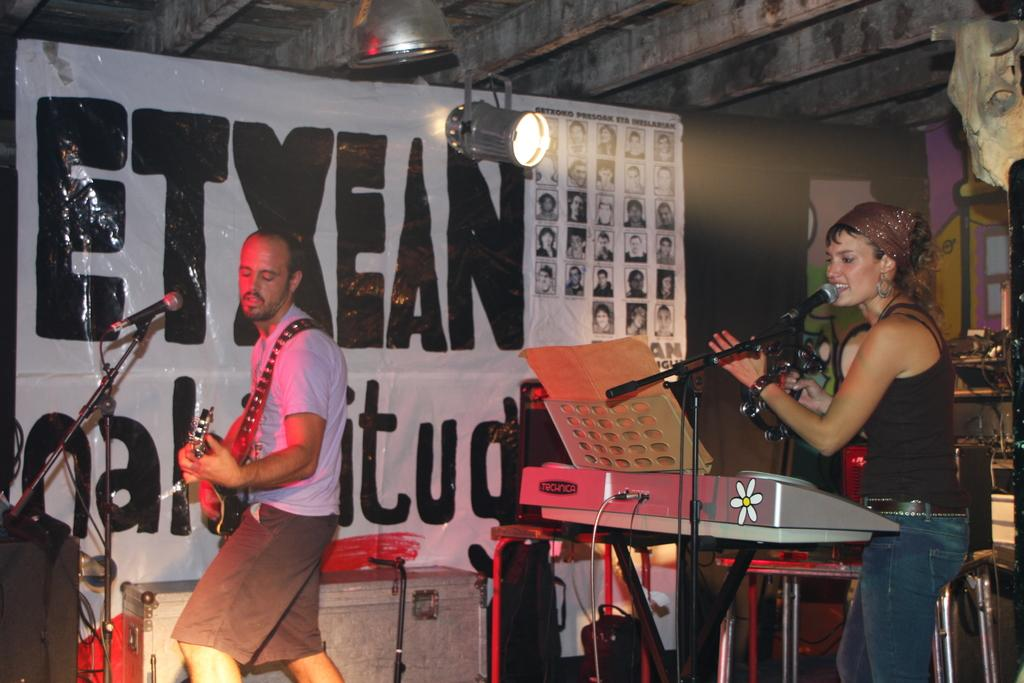How many people are in the image? There are two people standing in the image. What is the person on the left doing? The person on the left is playing a guitar. What can be seen on the banner in the image? There is a banner in the image with "etxeal" written on it. What is present above the banner in the image? There is nothing mentioned in the facts about what is present above the banner. What type of jellyfish can be seen swimming above the banner in the image? There are no jellyfish present in the image, and nothing is mentioned about them in the facts. 